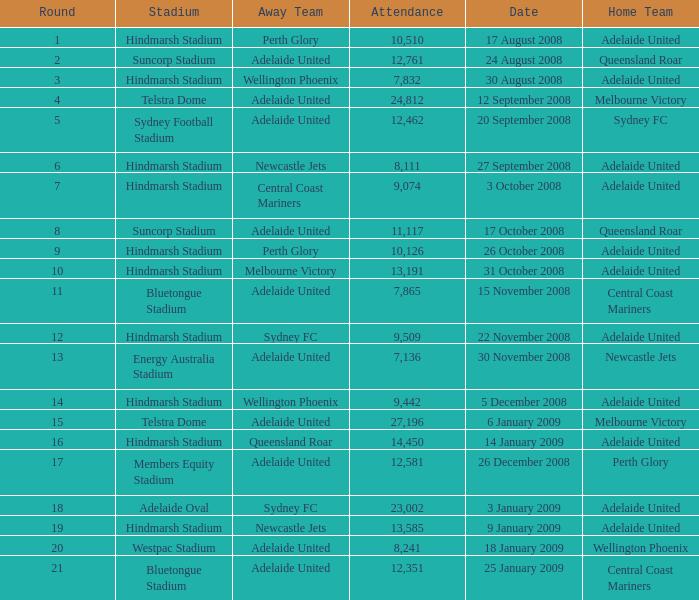What is the least round for the game played at Members Equity Stadium in from of 12,581 people? None. 